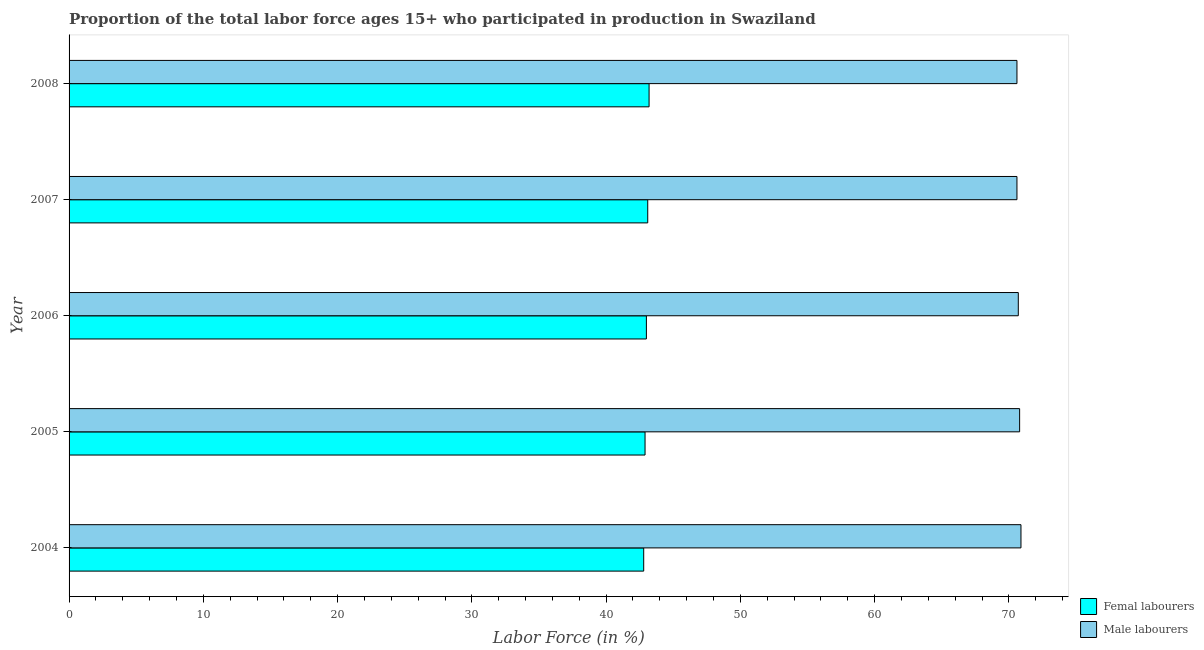In how many cases, is the number of bars for a given year not equal to the number of legend labels?
Provide a short and direct response. 0. What is the percentage of female labor force in 2004?
Give a very brief answer. 42.8. Across all years, what is the maximum percentage of female labor force?
Your answer should be very brief. 43.2. Across all years, what is the minimum percentage of male labour force?
Your answer should be compact. 70.6. In which year was the percentage of male labour force maximum?
Your response must be concise. 2004. What is the total percentage of male labour force in the graph?
Offer a terse response. 353.6. What is the difference between the percentage of female labor force in 2004 and the percentage of male labour force in 2008?
Your response must be concise. -27.8. What is the average percentage of female labor force per year?
Your answer should be very brief. 43. In the year 2004, what is the difference between the percentage of male labour force and percentage of female labor force?
Provide a short and direct response. 28.1. In how many years, is the percentage of female labor force greater than 28 %?
Your answer should be compact. 5. What is the ratio of the percentage of male labour force in 2004 to that in 2006?
Keep it short and to the point. 1. Is the percentage of female labor force in 2006 less than that in 2007?
Your response must be concise. Yes. What is the difference between the highest and the lowest percentage of female labor force?
Make the answer very short. 0.4. In how many years, is the percentage of female labor force greater than the average percentage of female labor force taken over all years?
Provide a short and direct response. 2. Is the sum of the percentage of male labour force in 2006 and 2007 greater than the maximum percentage of female labor force across all years?
Keep it short and to the point. Yes. What does the 2nd bar from the top in 2007 represents?
Give a very brief answer. Femal labourers. What does the 2nd bar from the bottom in 2004 represents?
Your answer should be very brief. Male labourers. How many bars are there?
Make the answer very short. 10. Are all the bars in the graph horizontal?
Make the answer very short. Yes. What is the difference between two consecutive major ticks on the X-axis?
Provide a short and direct response. 10. Are the values on the major ticks of X-axis written in scientific E-notation?
Your answer should be compact. No. Does the graph contain grids?
Your answer should be compact. No. How many legend labels are there?
Your answer should be compact. 2. What is the title of the graph?
Keep it short and to the point. Proportion of the total labor force ages 15+ who participated in production in Swaziland. Does "Number of arrivals" appear as one of the legend labels in the graph?
Provide a short and direct response. No. What is the label or title of the X-axis?
Provide a succinct answer. Labor Force (in %). What is the Labor Force (in %) of Femal labourers in 2004?
Keep it short and to the point. 42.8. What is the Labor Force (in %) in Male labourers in 2004?
Offer a terse response. 70.9. What is the Labor Force (in %) in Femal labourers in 2005?
Offer a very short reply. 42.9. What is the Labor Force (in %) of Male labourers in 2005?
Provide a short and direct response. 70.8. What is the Labor Force (in %) in Male labourers in 2006?
Your answer should be very brief. 70.7. What is the Labor Force (in %) in Femal labourers in 2007?
Offer a terse response. 43.1. What is the Labor Force (in %) in Male labourers in 2007?
Offer a terse response. 70.6. What is the Labor Force (in %) in Femal labourers in 2008?
Keep it short and to the point. 43.2. What is the Labor Force (in %) of Male labourers in 2008?
Offer a terse response. 70.6. Across all years, what is the maximum Labor Force (in %) in Femal labourers?
Give a very brief answer. 43.2. Across all years, what is the maximum Labor Force (in %) of Male labourers?
Make the answer very short. 70.9. Across all years, what is the minimum Labor Force (in %) in Femal labourers?
Keep it short and to the point. 42.8. Across all years, what is the minimum Labor Force (in %) in Male labourers?
Make the answer very short. 70.6. What is the total Labor Force (in %) in Femal labourers in the graph?
Your response must be concise. 215. What is the total Labor Force (in %) of Male labourers in the graph?
Give a very brief answer. 353.6. What is the difference between the Labor Force (in %) in Femal labourers in 2004 and that in 2005?
Provide a succinct answer. -0.1. What is the difference between the Labor Force (in %) in Femal labourers in 2004 and that in 2006?
Your answer should be very brief. -0.2. What is the difference between the Labor Force (in %) in Femal labourers in 2004 and that in 2008?
Your response must be concise. -0.4. What is the difference between the Labor Force (in %) of Male labourers in 2004 and that in 2008?
Ensure brevity in your answer.  0.3. What is the difference between the Labor Force (in %) of Femal labourers in 2005 and that in 2006?
Your answer should be very brief. -0.1. What is the difference between the Labor Force (in %) in Male labourers in 2005 and that in 2007?
Keep it short and to the point. 0.2. What is the difference between the Labor Force (in %) in Femal labourers in 2005 and that in 2008?
Make the answer very short. -0.3. What is the difference between the Labor Force (in %) of Male labourers in 2005 and that in 2008?
Your response must be concise. 0.2. What is the difference between the Labor Force (in %) of Femal labourers in 2006 and that in 2008?
Keep it short and to the point. -0.2. What is the difference between the Labor Force (in %) of Male labourers in 2006 and that in 2008?
Your answer should be very brief. 0.1. What is the difference between the Labor Force (in %) of Male labourers in 2007 and that in 2008?
Keep it short and to the point. 0. What is the difference between the Labor Force (in %) of Femal labourers in 2004 and the Labor Force (in %) of Male labourers in 2006?
Keep it short and to the point. -27.9. What is the difference between the Labor Force (in %) of Femal labourers in 2004 and the Labor Force (in %) of Male labourers in 2007?
Your answer should be compact. -27.8. What is the difference between the Labor Force (in %) of Femal labourers in 2004 and the Labor Force (in %) of Male labourers in 2008?
Offer a terse response. -27.8. What is the difference between the Labor Force (in %) of Femal labourers in 2005 and the Labor Force (in %) of Male labourers in 2006?
Ensure brevity in your answer.  -27.8. What is the difference between the Labor Force (in %) in Femal labourers in 2005 and the Labor Force (in %) in Male labourers in 2007?
Your response must be concise. -27.7. What is the difference between the Labor Force (in %) in Femal labourers in 2005 and the Labor Force (in %) in Male labourers in 2008?
Offer a very short reply. -27.7. What is the difference between the Labor Force (in %) in Femal labourers in 2006 and the Labor Force (in %) in Male labourers in 2007?
Offer a very short reply. -27.6. What is the difference between the Labor Force (in %) in Femal labourers in 2006 and the Labor Force (in %) in Male labourers in 2008?
Ensure brevity in your answer.  -27.6. What is the difference between the Labor Force (in %) of Femal labourers in 2007 and the Labor Force (in %) of Male labourers in 2008?
Keep it short and to the point. -27.5. What is the average Labor Force (in %) of Femal labourers per year?
Keep it short and to the point. 43. What is the average Labor Force (in %) in Male labourers per year?
Keep it short and to the point. 70.72. In the year 2004, what is the difference between the Labor Force (in %) of Femal labourers and Labor Force (in %) of Male labourers?
Keep it short and to the point. -28.1. In the year 2005, what is the difference between the Labor Force (in %) in Femal labourers and Labor Force (in %) in Male labourers?
Provide a succinct answer. -27.9. In the year 2006, what is the difference between the Labor Force (in %) in Femal labourers and Labor Force (in %) in Male labourers?
Your answer should be very brief. -27.7. In the year 2007, what is the difference between the Labor Force (in %) of Femal labourers and Labor Force (in %) of Male labourers?
Provide a succinct answer. -27.5. In the year 2008, what is the difference between the Labor Force (in %) in Femal labourers and Labor Force (in %) in Male labourers?
Provide a succinct answer. -27.4. What is the ratio of the Labor Force (in %) of Femal labourers in 2004 to that in 2006?
Provide a short and direct response. 1. What is the ratio of the Labor Force (in %) of Male labourers in 2004 to that in 2007?
Offer a terse response. 1. What is the ratio of the Labor Force (in %) of Femal labourers in 2004 to that in 2008?
Provide a succinct answer. 0.99. What is the ratio of the Labor Force (in %) of Male labourers in 2004 to that in 2008?
Make the answer very short. 1. What is the ratio of the Labor Force (in %) of Femal labourers in 2005 to that in 2006?
Your answer should be compact. 1. What is the ratio of the Labor Force (in %) in Male labourers in 2005 to that in 2006?
Your response must be concise. 1. What is the ratio of the Labor Force (in %) of Male labourers in 2005 to that in 2007?
Give a very brief answer. 1. What is the ratio of the Labor Force (in %) of Femal labourers in 2005 to that in 2008?
Offer a terse response. 0.99. What is the ratio of the Labor Force (in %) in Male labourers in 2005 to that in 2008?
Offer a terse response. 1. What is the ratio of the Labor Force (in %) of Femal labourers in 2006 to that in 2007?
Give a very brief answer. 1. What is the ratio of the Labor Force (in %) of Male labourers in 2006 to that in 2007?
Ensure brevity in your answer.  1. What is the ratio of the Labor Force (in %) in Femal labourers in 2006 to that in 2008?
Your response must be concise. 1. What is the ratio of the Labor Force (in %) of Male labourers in 2006 to that in 2008?
Offer a very short reply. 1. What is the ratio of the Labor Force (in %) in Femal labourers in 2007 to that in 2008?
Offer a very short reply. 1. What is the ratio of the Labor Force (in %) in Male labourers in 2007 to that in 2008?
Provide a succinct answer. 1. What is the difference between the highest and the second highest Labor Force (in %) of Femal labourers?
Offer a terse response. 0.1. What is the difference between the highest and the lowest Labor Force (in %) in Femal labourers?
Your answer should be compact. 0.4. 